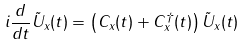Convert formula to latex. <formula><loc_0><loc_0><loc_500><loc_500>i \frac { d } { d t } \tilde { U } _ { x } ( t ) = \left ( C _ { x } ( t ) + C ^ { \dagger } _ { x } ( t ) \right ) \tilde { U } _ { x } ( t )</formula> 